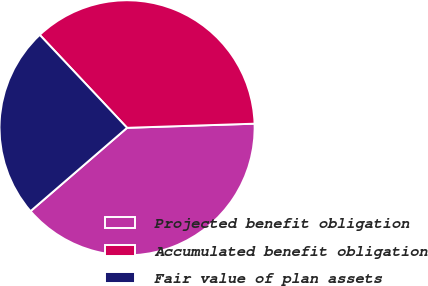Convert chart. <chart><loc_0><loc_0><loc_500><loc_500><pie_chart><fcel>Projected benefit obligation<fcel>Accumulated benefit obligation<fcel>Fair value of plan assets<nl><fcel>39.18%<fcel>36.49%<fcel>24.33%<nl></chart> 